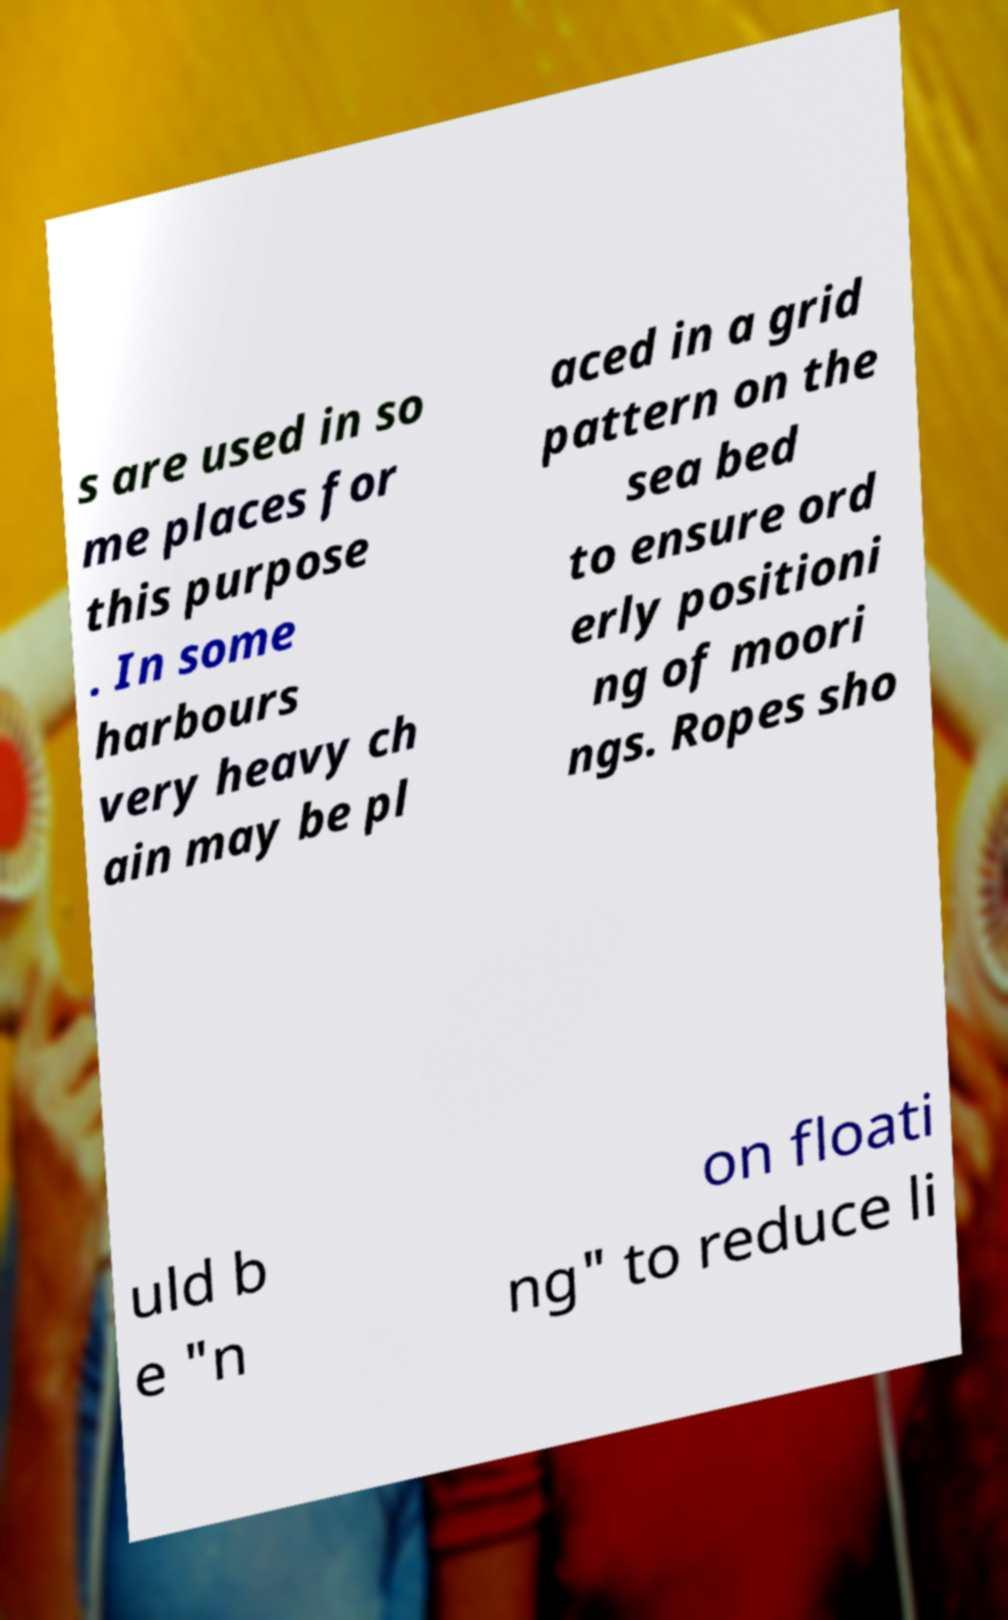What messages or text are displayed in this image? I need them in a readable, typed format. s are used in so me places for this purpose . In some harbours very heavy ch ain may be pl aced in a grid pattern on the sea bed to ensure ord erly positioni ng of moori ngs. Ropes sho uld b e "n on floati ng" to reduce li 